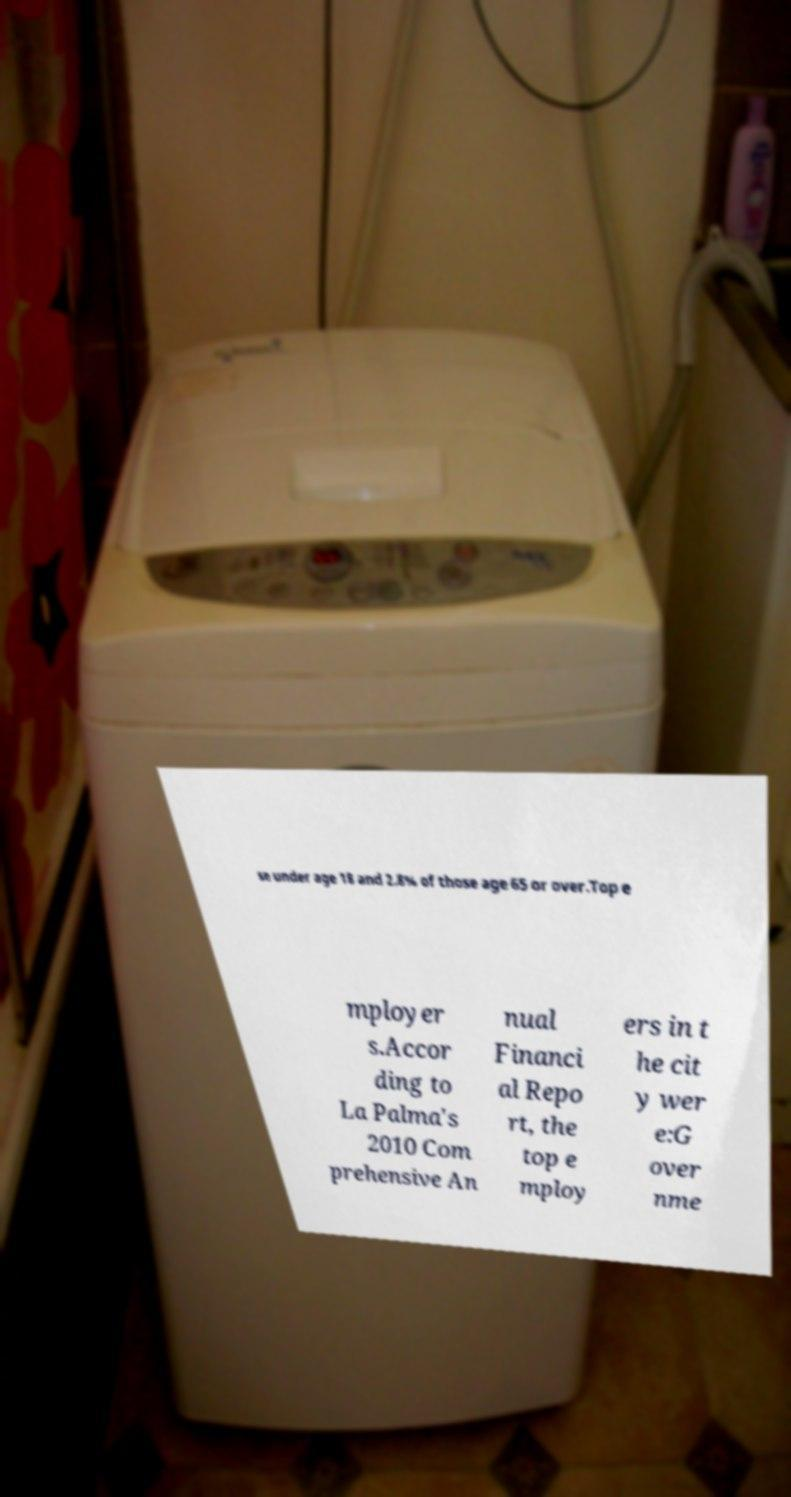Could you extract and type out the text from this image? se under age 18 and 2.8% of those age 65 or over.Top e mployer s.Accor ding to La Palma's 2010 Com prehensive An nual Financi al Repo rt, the top e mploy ers in t he cit y wer e:G over nme 